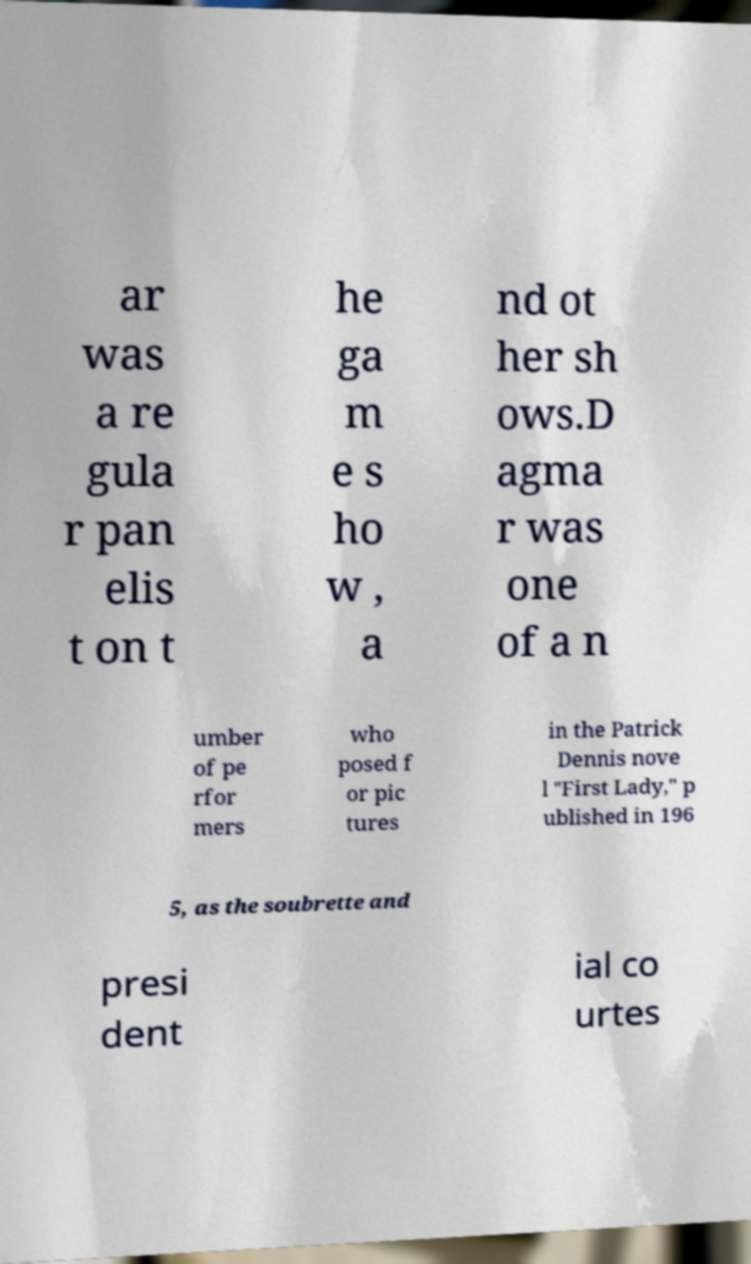I need the written content from this picture converted into text. Can you do that? ar was a re gula r pan elis t on t he ga m e s ho w , a nd ot her sh ows.D agma r was one of a n umber of pe rfor mers who posed f or pic tures in the Patrick Dennis nove l "First Lady," p ublished in 196 5, as the soubrette and presi dent ial co urtes 